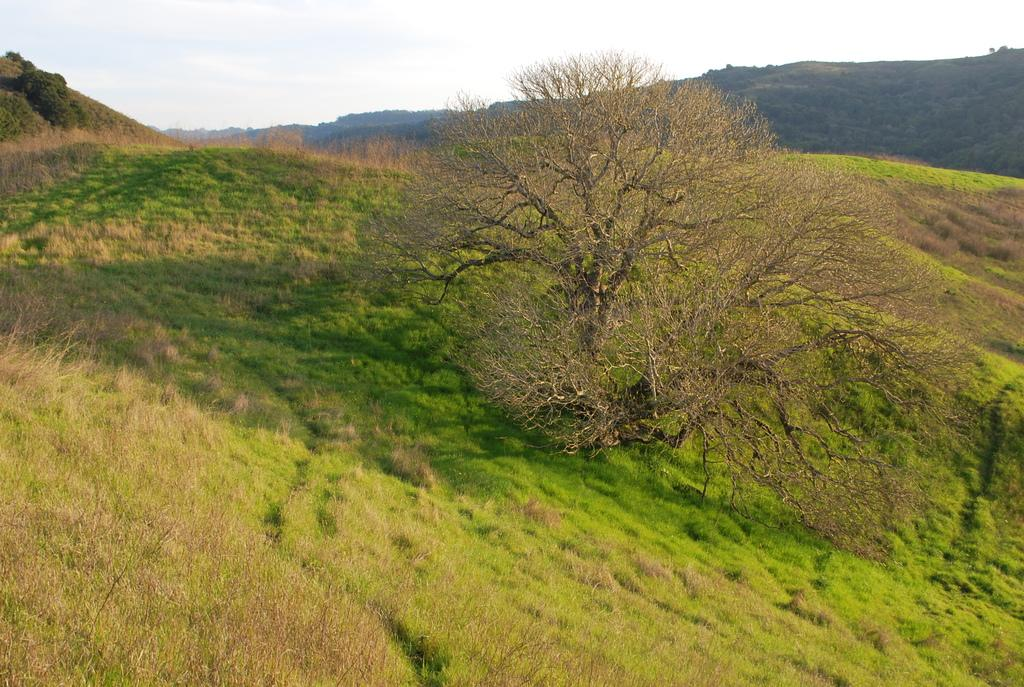What type of landscape is depicted in the image? The image features hills. What type of vegetation can be seen in the image? There are trees, plants, and grass visible in the image. What is visible in the sky in the image? The sky is visible in the image. How many clovers can be seen growing in the image? There is no mention of clovers in the image, so it is impossible to determine how many might be present. What type of bird can be seen flying in the image? There is no bird visible in the image. 